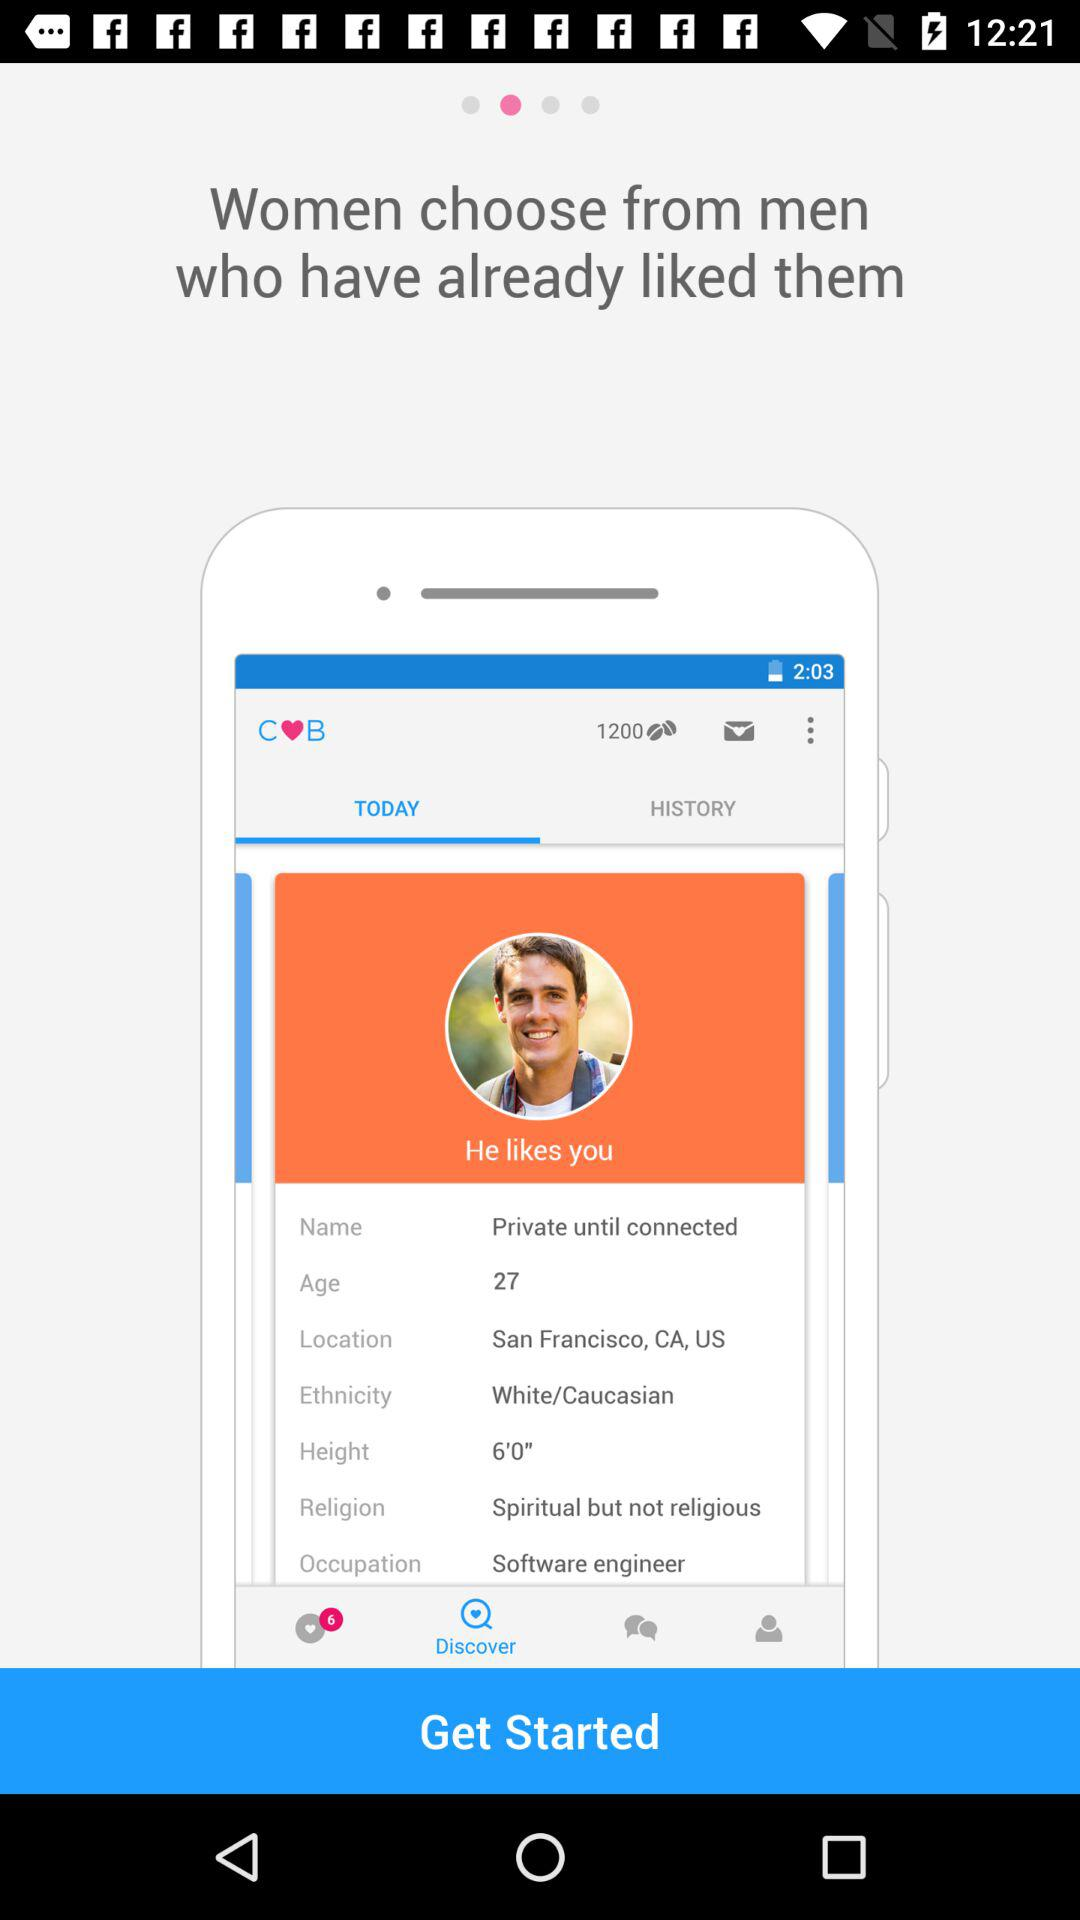The height of the person is what? The height of the person is 6'0". 